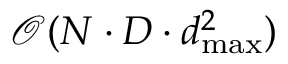Convert formula to latex. <formula><loc_0><loc_0><loc_500><loc_500>\mathcal { O } ( N \cdot D \cdot d _ { \max } ^ { 2 } )</formula> 